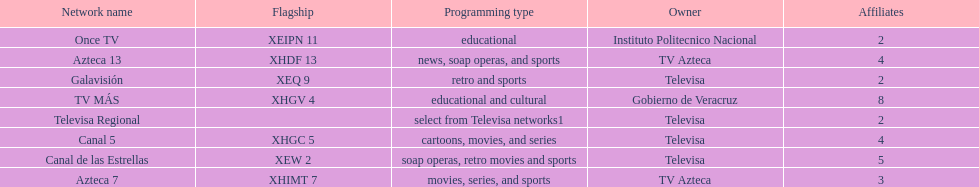How many networks have more affiliates than canal de las estrellas? 1. 